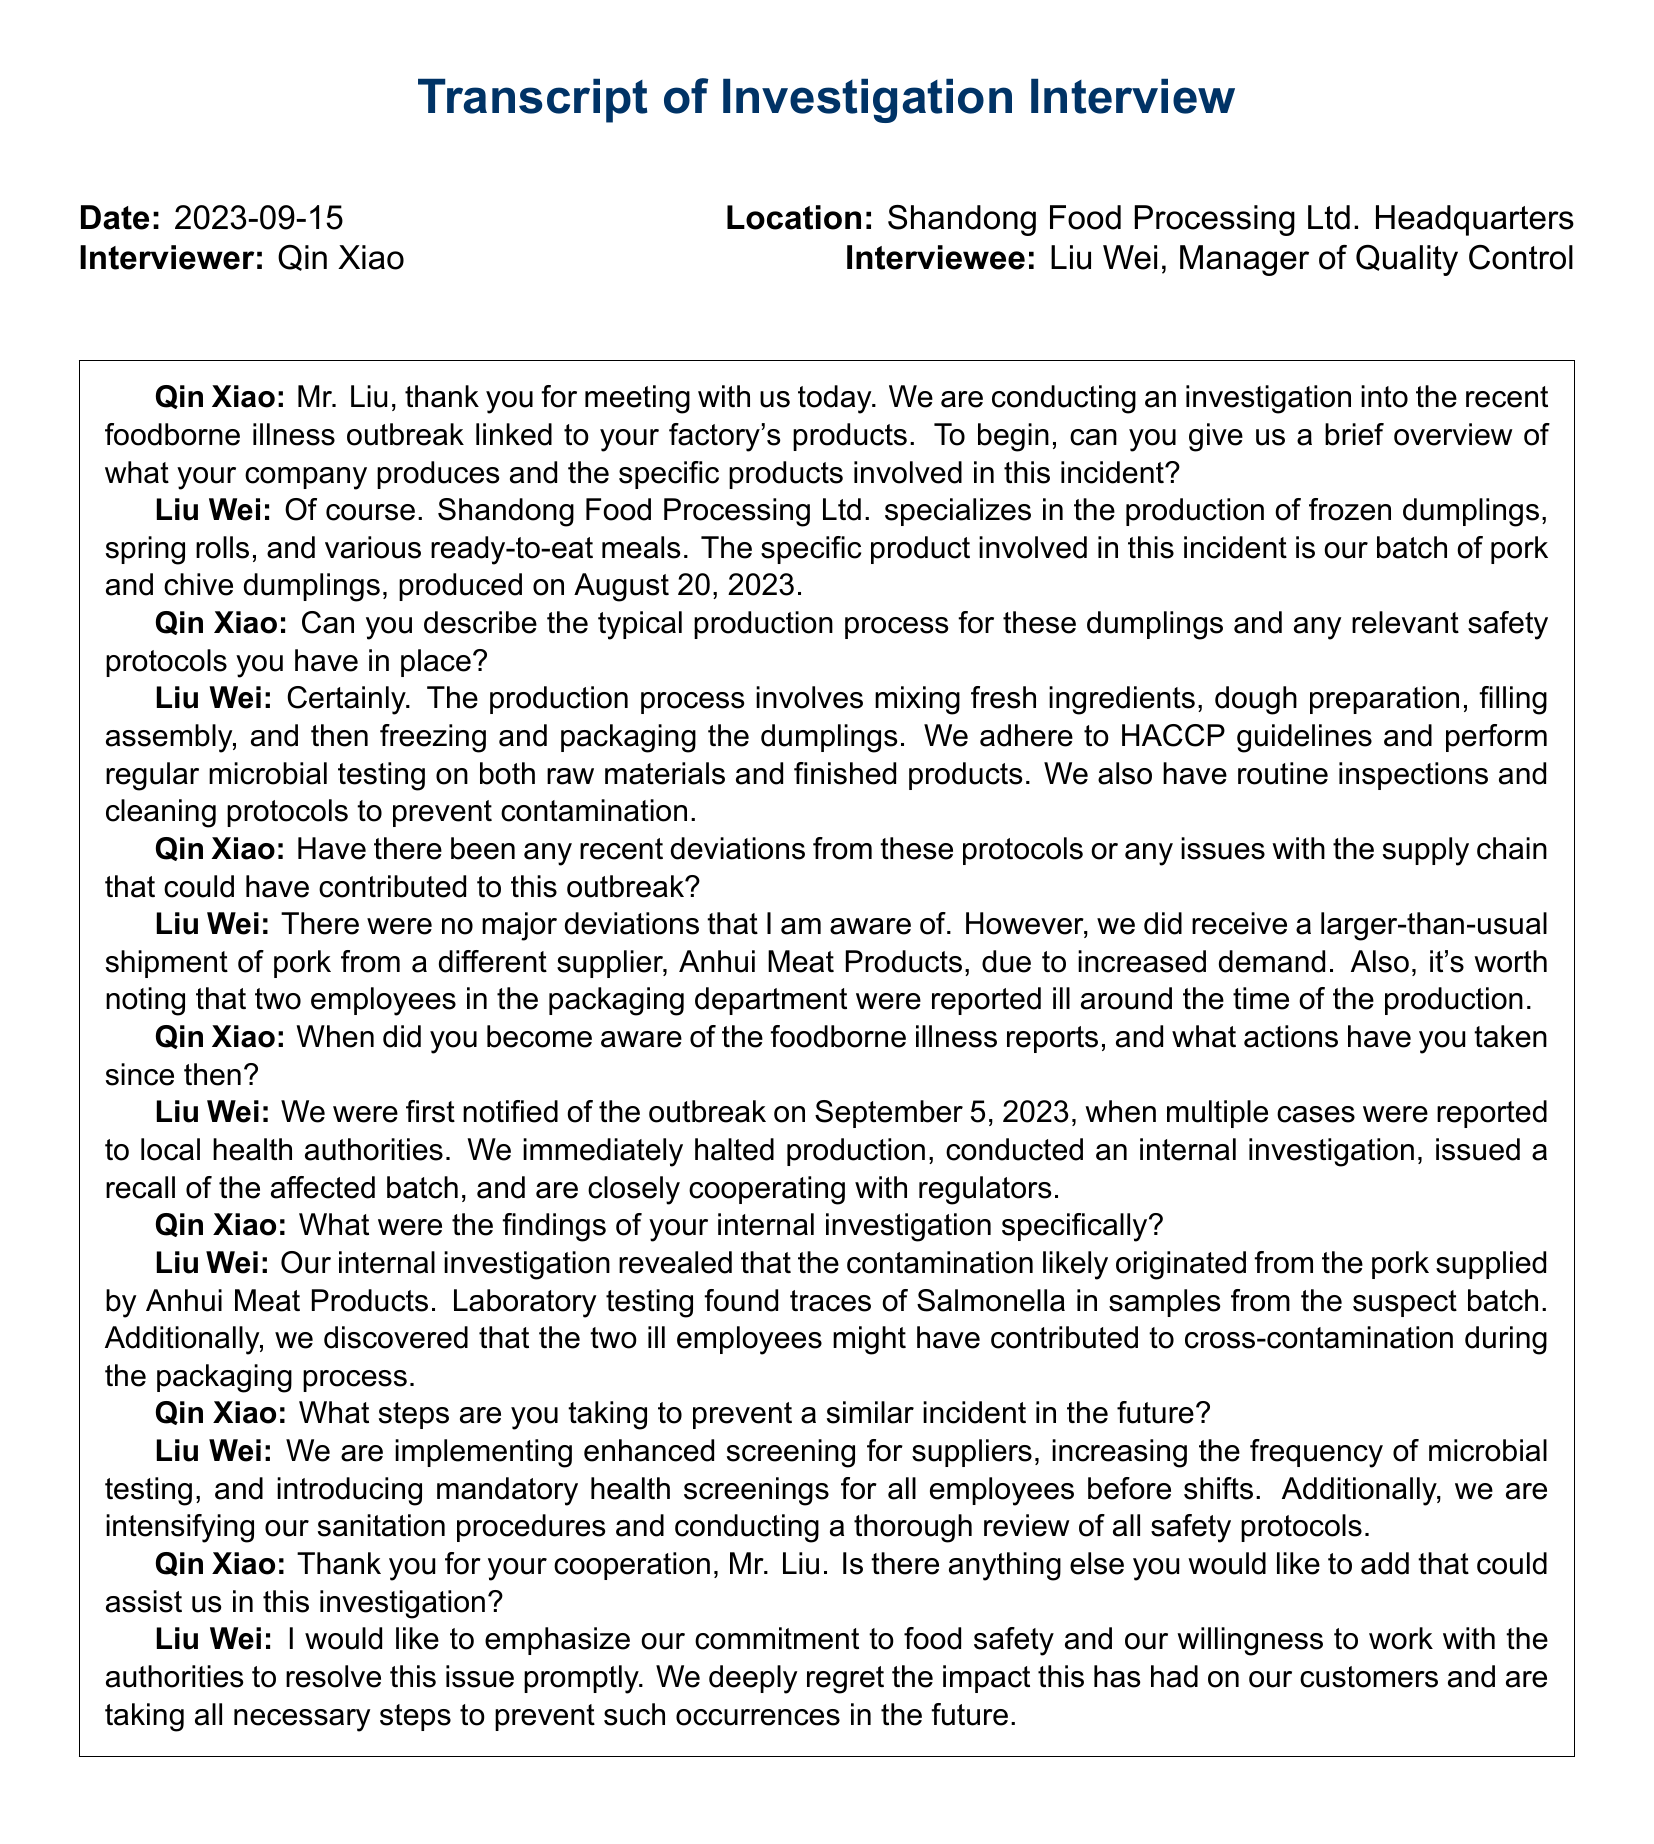What date did the interview take place? The date of the interview is noted in the document header.
Answer: 2023-09-15 Who is the interviewee in the transcript? The transcript states that the interviewee is the Manager of Quality Control.
Answer: Liu Wei What product was linked to the foodborne illness outbreak? The specific product involved in the incident is mentioned in Liu Wei's response during the interview.
Answer: Pork and chive dumplings When was the dumpling batch produced? Liu Wei indicates the production date of the dumplings during the interview.
Answer: August 20, 2023 What pathogen was found in the testing of the pork batch? The internal investigation's findings specify the pathogen detected in the samples.
Answer: Salmonella What supplier did Shandong Food Processing Ltd. receive a larger shipment from? Liu Wei references the supplier of the pork when discussing supply chain issues.
Answer: Anhui Meat Products What action was taken immediately upon notification of the outbreak? Liu Wei's response includes the action taken after the awareness of the outbreak.
Answer: Halted production What health measure is being introduced for employees? Liu Wei mentions a new health protocol to be implemented for employees.
Answer: Mandatory health screenings What does Liu Wei emphasize at the end of the interview? The closing statements from Liu Wei reflect the company's stance on food safety.
Answer: Commitment to food safety 